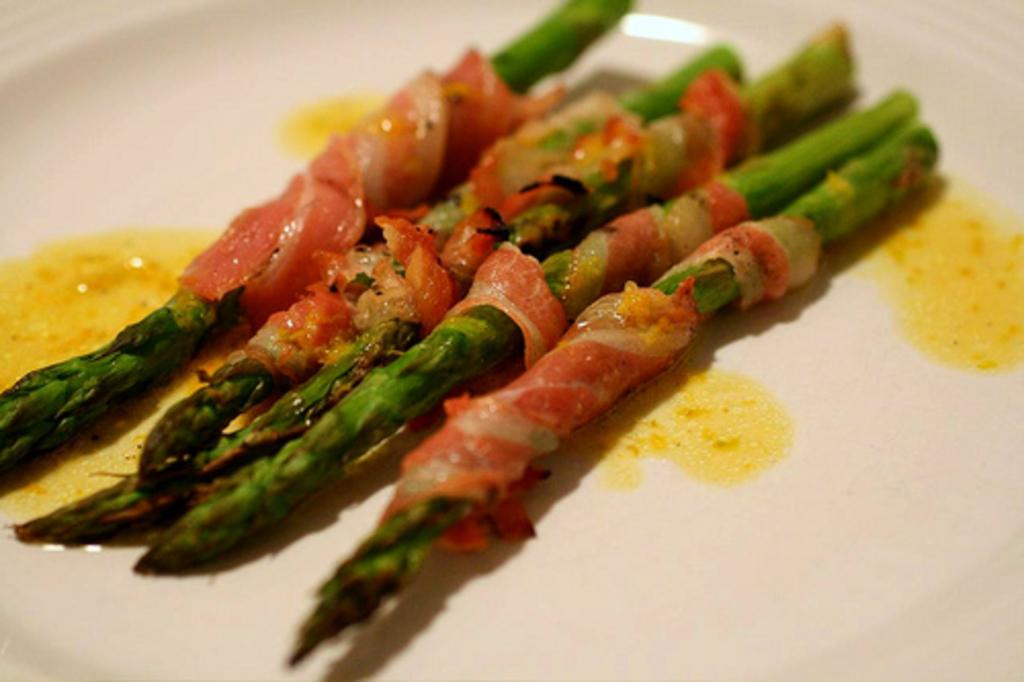What is the main subject of the image? There is a food item in the image. How is the food item presented in the image? The food item is in a plate. What type of carpenter is working at the zoo in the image? There is no carpenter or zoo present in the image; it only features a food item in a plate. 